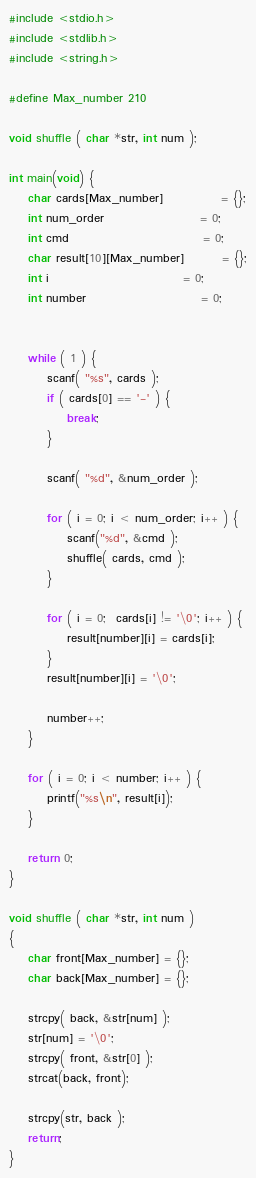Convert code to text. <code><loc_0><loc_0><loc_500><loc_500><_C_>#include <stdio.h>
#include <stdlib.h>
#include <string.h>

#define Max_number 210

void shuffle ( char *str, int num );

int main(void) {
	char cards[Max_number]			= {};
	int num_order					= 0;
	int cmd							= 0;
	char result[10][Max_number]		= {};
	int i							= 0;
	int number						= 0;
	
	
	while ( 1 ) {
		scanf( "%s", cards );
		if ( cards[0] == '-' ) {
			break;
		}
		
		scanf( "%d", &num_order );
		
		for ( i = 0; i < num_order; i++ ) {
			scanf("%d", &cmd );
			shuffle( cards, cmd );
		}
		
		for ( i = 0;  cards[i] != '\0'; i++ ) {
			result[number][i] = cards[i];
		}
		result[number][i] = '\0';
		
		number++;
	}
	
	for ( i = 0; i < number; i++ ) {
	    printf("%s\n", result[i]);
	}
	
	return 0;
}

void shuffle ( char *str, int num )
{
	char front[Max_number] = {};
	char back[Max_number] = {};

	strcpy( back, &str[num] );
	str[num] = '\0';
	strcpy( front, &str[0] );
	strcat(back, front);
	
	strcpy(str, back );
	return;
}
</code> 